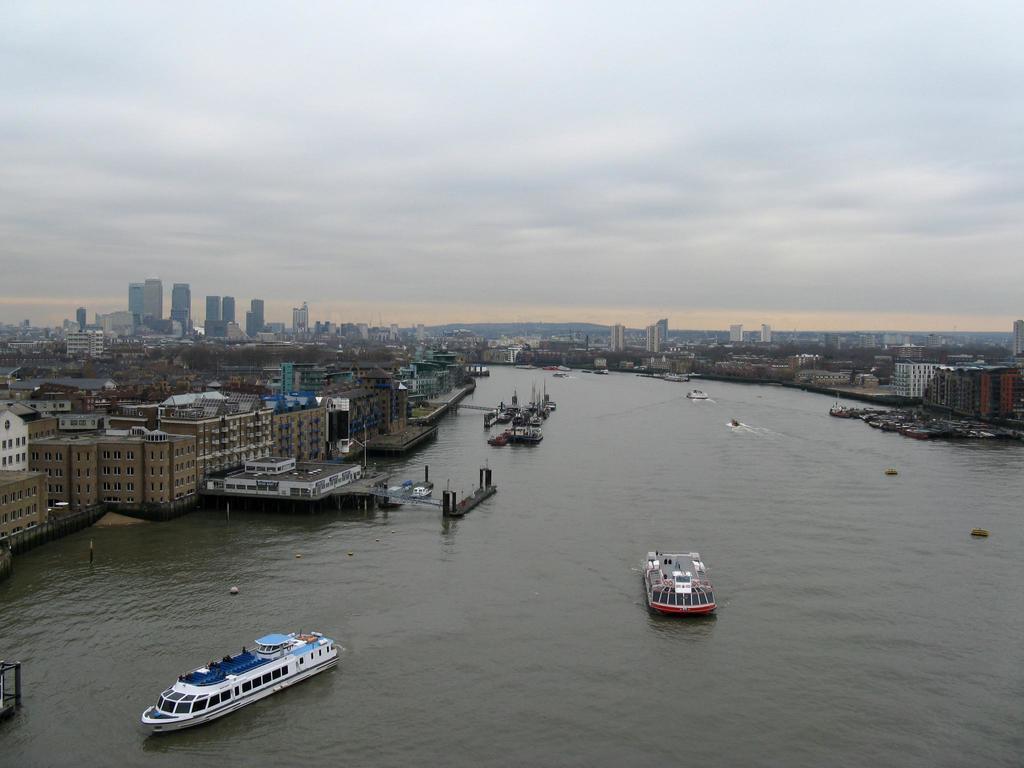What is happening in the water in the image? There are boats on water in the image. What structures can be seen in the image? There are buildings visible in the image. What type of vegetation is present in the image? There are trees in the image. What can be seen in the background of the image? The sky is visible in the background of the image. What is the condition of the sky in the image? Clouds are present in the sky. What type of division can be seen between the trees and the buildings in the image? There is no division between the trees and the buildings mentioned in the image; they are simply present in the scene. Is there a jar visible in the image? There is no jar present in the image. 